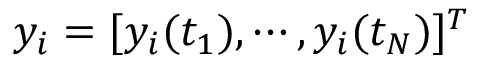Convert formula to latex. <formula><loc_0><loc_0><loc_500><loc_500>y _ { i } = [ y _ { i } ( t _ { 1 } ) , \cdots , y _ { i } ( t _ { N } ) ] ^ { T }</formula> 